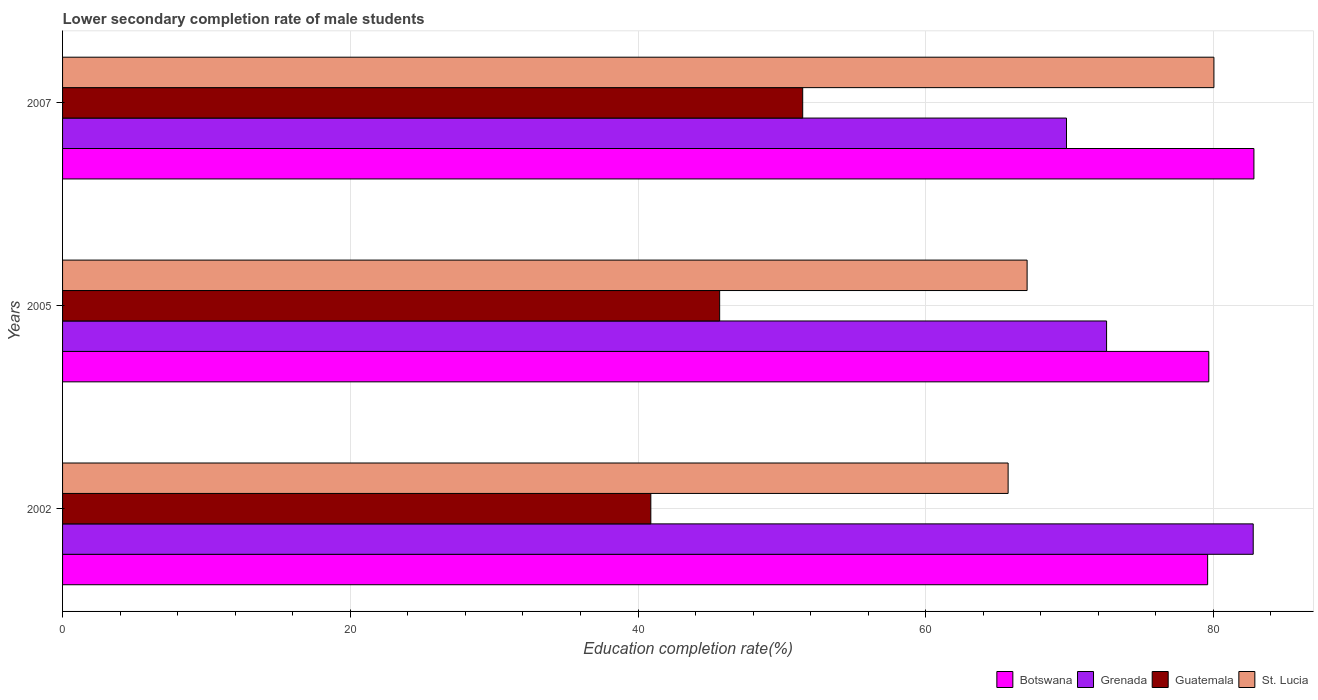How many groups of bars are there?
Provide a succinct answer. 3. Are the number of bars per tick equal to the number of legend labels?
Make the answer very short. Yes. How many bars are there on the 2nd tick from the bottom?
Provide a short and direct response. 4. In how many cases, is the number of bars for a given year not equal to the number of legend labels?
Your answer should be compact. 0. What is the lower secondary completion rate of male students in Guatemala in 2002?
Give a very brief answer. 40.89. Across all years, what is the maximum lower secondary completion rate of male students in Guatemala?
Give a very brief answer. 51.45. Across all years, what is the minimum lower secondary completion rate of male students in Grenada?
Provide a short and direct response. 69.79. What is the total lower secondary completion rate of male students in St. Lucia in the graph?
Provide a short and direct response. 212.81. What is the difference between the lower secondary completion rate of male students in St. Lucia in 2002 and that in 2007?
Offer a terse response. -14.31. What is the difference between the lower secondary completion rate of male students in Guatemala in 2005 and the lower secondary completion rate of male students in Botswana in 2002?
Make the answer very short. -33.92. What is the average lower secondary completion rate of male students in St. Lucia per year?
Your answer should be very brief. 70.94. In the year 2007, what is the difference between the lower secondary completion rate of male students in Guatemala and lower secondary completion rate of male students in Grenada?
Give a very brief answer. -18.34. What is the ratio of the lower secondary completion rate of male students in Grenada in 2002 to that in 2007?
Offer a terse response. 1.19. Is the lower secondary completion rate of male students in Botswana in 2002 less than that in 2005?
Offer a terse response. Yes. What is the difference between the highest and the second highest lower secondary completion rate of male students in Grenada?
Give a very brief answer. 10.19. What is the difference between the highest and the lowest lower secondary completion rate of male students in Guatemala?
Your response must be concise. 10.56. Is it the case that in every year, the sum of the lower secondary completion rate of male students in St. Lucia and lower secondary completion rate of male students in Guatemala is greater than the sum of lower secondary completion rate of male students in Botswana and lower secondary completion rate of male students in Grenada?
Your answer should be compact. No. What does the 3rd bar from the top in 2002 represents?
Provide a short and direct response. Grenada. What does the 4th bar from the bottom in 2007 represents?
Your response must be concise. St. Lucia. How many bars are there?
Your answer should be very brief. 12. Does the graph contain any zero values?
Your response must be concise. No. How many legend labels are there?
Provide a succinct answer. 4. What is the title of the graph?
Your answer should be very brief. Lower secondary completion rate of male students. What is the label or title of the X-axis?
Offer a very short reply. Education completion rate(%). What is the label or title of the Y-axis?
Ensure brevity in your answer.  Years. What is the Education completion rate(%) in Botswana in 2002?
Keep it short and to the point. 79.6. What is the Education completion rate(%) of Grenada in 2002?
Offer a very short reply. 82.77. What is the Education completion rate(%) in Guatemala in 2002?
Your response must be concise. 40.89. What is the Education completion rate(%) in St. Lucia in 2002?
Your response must be concise. 65.73. What is the Education completion rate(%) of Botswana in 2005?
Make the answer very short. 79.68. What is the Education completion rate(%) of Grenada in 2005?
Your answer should be very brief. 72.57. What is the Education completion rate(%) of Guatemala in 2005?
Provide a succinct answer. 45.68. What is the Education completion rate(%) of St. Lucia in 2005?
Your answer should be compact. 67.05. What is the Education completion rate(%) in Botswana in 2007?
Offer a very short reply. 82.82. What is the Education completion rate(%) of Grenada in 2007?
Give a very brief answer. 69.79. What is the Education completion rate(%) of Guatemala in 2007?
Make the answer very short. 51.45. What is the Education completion rate(%) of St. Lucia in 2007?
Your answer should be compact. 80.03. Across all years, what is the maximum Education completion rate(%) in Botswana?
Provide a succinct answer. 82.82. Across all years, what is the maximum Education completion rate(%) of Grenada?
Give a very brief answer. 82.77. Across all years, what is the maximum Education completion rate(%) of Guatemala?
Keep it short and to the point. 51.45. Across all years, what is the maximum Education completion rate(%) in St. Lucia?
Keep it short and to the point. 80.03. Across all years, what is the minimum Education completion rate(%) in Botswana?
Offer a terse response. 79.6. Across all years, what is the minimum Education completion rate(%) in Grenada?
Provide a succinct answer. 69.79. Across all years, what is the minimum Education completion rate(%) in Guatemala?
Offer a terse response. 40.89. Across all years, what is the minimum Education completion rate(%) in St. Lucia?
Your answer should be compact. 65.73. What is the total Education completion rate(%) of Botswana in the graph?
Offer a very short reply. 242.09. What is the total Education completion rate(%) in Grenada in the graph?
Make the answer very short. 225.13. What is the total Education completion rate(%) of Guatemala in the graph?
Provide a succinct answer. 138.02. What is the total Education completion rate(%) in St. Lucia in the graph?
Your answer should be compact. 212.81. What is the difference between the Education completion rate(%) in Botswana in 2002 and that in 2005?
Your answer should be very brief. -0.08. What is the difference between the Education completion rate(%) in Grenada in 2002 and that in 2005?
Keep it short and to the point. 10.19. What is the difference between the Education completion rate(%) in Guatemala in 2002 and that in 2005?
Make the answer very short. -4.78. What is the difference between the Education completion rate(%) in St. Lucia in 2002 and that in 2005?
Your answer should be compact. -1.32. What is the difference between the Education completion rate(%) of Botswana in 2002 and that in 2007?
Offer a very short reply. -3.22. What is the difference between the Education completion rate(%) in Grenada in 2002 and that in 2007?
Provide a short and direct response. 12.98. What is the difference between the Education completion rate(%) of Guatemala in 2002 and that in 2007?
Your answer should be compact. -10.56. What is the difference between the Education completion rate(%) of St. Lucia in 2002 and that in 2007?
Give a very brief answer. -14.31. What is the difference between the Education completion rate(%) in Botswana in 2005 and that in 2007?
Provide a short and direct response. -3.14. What is the difference between the Education completion rate(%) of Grenada in 2005 and that in 2007?
Provide a succinct answer. 2.79. What is the difference between the Education completion rate(%) of Guatemala in 2005 and that in 2007?
Offer a very short reply. -5.77. What is the difference between the Education completion rate(%) in St. Lucia in 2005 and that in 2007?
Offer a very short reply. -12.98. What is the difference between the Education completion rate(%) of Botswana in 2002 and the Education completion rate(%) of Grenada in 2005?
Keep it short and to the point. 7.03. What is the difference between the Education completion rate(%) in Botswana in 2002 and the Education completion rate(%) in Guatemala in 2005?
Your answer should be very brief. 33.92. What is the difference between the Education completion rate(%) of Botswana in 2002 and the Education completion rate(%) of St. Lucia in 2005?
Give a very brief answer. 12.55. What is the difference between the Education completion rate(%) of Grenada in 2002 and the Education completion rate(%) of Guatemala in 2005?
Offer a terse response. 37.09. What is the difference between the Education completion rate(%) of Grenada in 2002 and the Education completion rate(%) of St. Lucia in 2005?
Offer a terse response. 15.72. What is the difference between the Education completion rate(%) in Guatemala in 2002 and the Education completion rate(%) in St. Lucia in 2005?
Provide a short and direct response. -26.16. What is the difference between the Education completion rate(%) in Botswana in 2002 and the Education completion rate(%) in Grenada in 2007?
Your answer should be very brief. 9.81. What is the difference between the Education completion rate(%) of Botswana in 2002 and the Education completion rate(%) of Guatemala in 2007?
Keep it short and to the point. 28.15. What is the difference between the Education completion rate(%) in Botswana in 2002 and the Education completion rate(%) in St. Lucia in 2007?
Your response must be concise. -0.44. What is the difference between the Education completion rate(%) in Grenada in 2002 and the Education completion rate(%) in Guatemala in 2007?
Provide a short and direct response. 31.32. What is the difference between the Education completion rate(%) of Grenada in 2002 and the Education completion rate(%) of St. Lucia in 2007?
Your answer should be very brief. 2.73. What is the difference between the Education completion rate(%) in Guatemala in 2002 and the Education completion rate(%) in St. Lucia in 2007?
Your response must be concise. -39.14. What is the difference between the Education completion rate(%) of Botswana in 2005 and the Education completion rate(%) of Grenada in 2007?
Offer a terse response. 9.89. What is the difference between the Education completion rate(%) of Botswana in 2005 and the Education completion rate(%) of Guatemala in 2007?
Keep it short and to the point. 28.23. What is the difference between the Education completion rate(%) in Botswana in 2005 and the Education completion rate(%) in St. Lucia in 2007?
Your answer should be compact. -0.36. What is the difference between the Education completion rate(%) in Grenada in 2005 and the Education completion rate(%) in Guatemala in 2007?
Make the answer very short. 21.12. What is the difference between the Education completion rate(%) in Grenada in 2005 and the Education completion rate(%) in St. Lucia in 2007?
Offer a terse response. -7.46. What is the difference between the Education completion rate(%) in Guatemala in 2005 and the Education completion rate(%) in St. Lucia in 2007?
Keep it short and to the point. -34.36. What is the average Education completion rate(%) of Botswana per year?
Make the answer very short. 80.7. What is the average Education completion rate(%) in Grenada per year?
Make the answer very short. 75.04. What is the average Education completion rate(%) of Guatemala per year?
Offer a terse response. 46.01. What is the average Education completion rate(%) in St. Lucia per year?
Provide a short and direct response. 70.94. In the year 2002, what is the difference between the Education completion rate(%) of Botswana and Education completion rate(%) of Grenada?
Make the answer very short. -3.17. In the year 2002, what is the difference between the Education completion rate(%) of Botswana and Education completion rate(%) of Guatemala?
Keep it short and to the point. 38.71. In the year 2002, what is the difference between the Education completion rate(%) of Botswana and Education completion rate(%) of St. Lucia?
Make the answer very short. 13.87. In the year 2002, what is the difference between the Education completion rate(%) of Grenada and Education completion rate(%) of Guatemala?
Provide a short and direct response. 41.87. In the year 2002, what is the difference between the Education completion rate(%) in Grenada and Education completion rate(%) in St. Lucia?
Ensure brevity in your answer.  17.04. In the year 2002, what is the difference between the Education completion rate(%) in Guatemala and Education completion rate(%) in St. Lucia?
Make the answer very short. -24.84. In the year 2005, what is the difference between the Education completion rate(%) of Botswana and Education completion rate(%) of Grenada?
Make the answer very short. 7.11. In the year 2005, what is the difference between the Education completion rate(%) of Botswana and Education completion rate(%) of Guatemala?
Your answer should be compact. 34. In the year 2005, what is the difference between the Education completion rate(%) of Botswana and Education completion rate(%) of St. Lucia?
Your response must be concise. 12.63. In the year 2005, what is the difference between the Education completion rate(%) in Grenada and Education completion rate(%) in Guatemala?
Provide a short and direct response. 26.9. In the year 2005, what is the difference between the Education completion rate(%) of Grenada and Education completion rate(%) of St. Lucia?
Provide a succinct answer. 5.52. In the year 2005, what is the difference between the Education completion rate(%) in Guatemala and Education completion rate(%) in St. Lucia?
Your answer should be compact. -21.37. In the year 2007, what is the difference between the Education completion rate(%) of Botswana and Education completion rate(%) of Grenada?
Make the answer very short. 13.03. In the year 2007, what is the difference between the Education completion rate(%) of Botswana and Education completion rate(%) of Guatemala?
Make the answer very short. 31.37. In the year 2007, what is the difference between the Education completion rate(%) of Botswana and Education completion rate(%) of St. Lucia?
Your answer should be compact. 2.78. In the year 2007, what is the difference between the Education completion rate(%) in Grenada and Education completion rate(%) in Guatemala?
Keep it short and to the point. 18.34. In the year 2007, what is the difference between the Education completion rate(%) in Grenada and Education completion rate(%) in St. Lucia?
Your answer should be very brief. -10.25. In the year 2007, what is the difference between the Education completion rate(%) in Guatemala and Education completion rate(%) in St. Lucia?
Your answer should be compact. -28.58. What is the ratio of the Education completion rate(%) of Grenada in 2002 to that in 2005?
Your answer should be very brief. 1.14. What is the ratio of the Education completion rate(%) of Guatemala in 2002 to that in 2005?
Your response must be concise. 0.9. What is the ratio of the Education completion rate(%) in St. Lucia in 2002 to that in 2005?
Provide a short and direct response. 0.98. What is the ratio of the Education completion rate(%) in Botswana in 2002 to that in 2007?
Give a very brief answer. 0.96. What is the ratio of the Education completion rate(%) in Grenada in 2002 to that in 2007?
Provide a short and direct response. 1.19. What is the ratio of the Education completion rate(%) of Guatemala in 2002 to that in 2007?
Provide a short and direct response. 0.79. What is the ratio of the Education completion rate(%) in St. Lucia in 2002 to that in 2007?
Offer a terse response. 0.82. What is the ratio of the Education completion rate(%) in Botswana in 2005 to that in 2007?
Make the answer very short. 0.96. What is the ratio of the Education completion rate(%) in Grenada in 2005 to that in 2007?
Give a very brief answer. 1.04. What is the ratio of the Education completion rate(%) of Guatemala in 2005 to that in 2007?
Make the answer very short. 0.89. What is the ratio of the Education completion rate(%) of St. Lucia in 2005 to that in 2007?
Make the answer very short. 0.84. What is the difference between the highest and the second highest Education completion rate(%) of Botswana?
Give a very brief answer. 3.14. What is the difference between the highest and the second highest Education completion rate(%) of Grenada?
Keep it short and to the point. 10.19. What is the difference between the highest and the second highest Education completion rate(%) in Guatemala?
Give a very brief answer. 5.77. What is the difference between the highest and the second highest Education completion rate(%) of St. Lucia?
Keep it short and to the point. 12.98. What is the difference between the highest and the lowest Education completion rate(%) in Botswana?
Offer a terse response. 3.22. What is the difference between the highest and the lowest Education completion rate(%) in Grenada?
Give a very brief answer. 12.98. What is the difference between the highest and the lowest Education completion rate(%) of Guatemala?
Offer a terse response. 10.56. What is the difference between the highest and the lowest Education completion rate(%) of St. Lucia?
Offer a terse response. 14.31. 